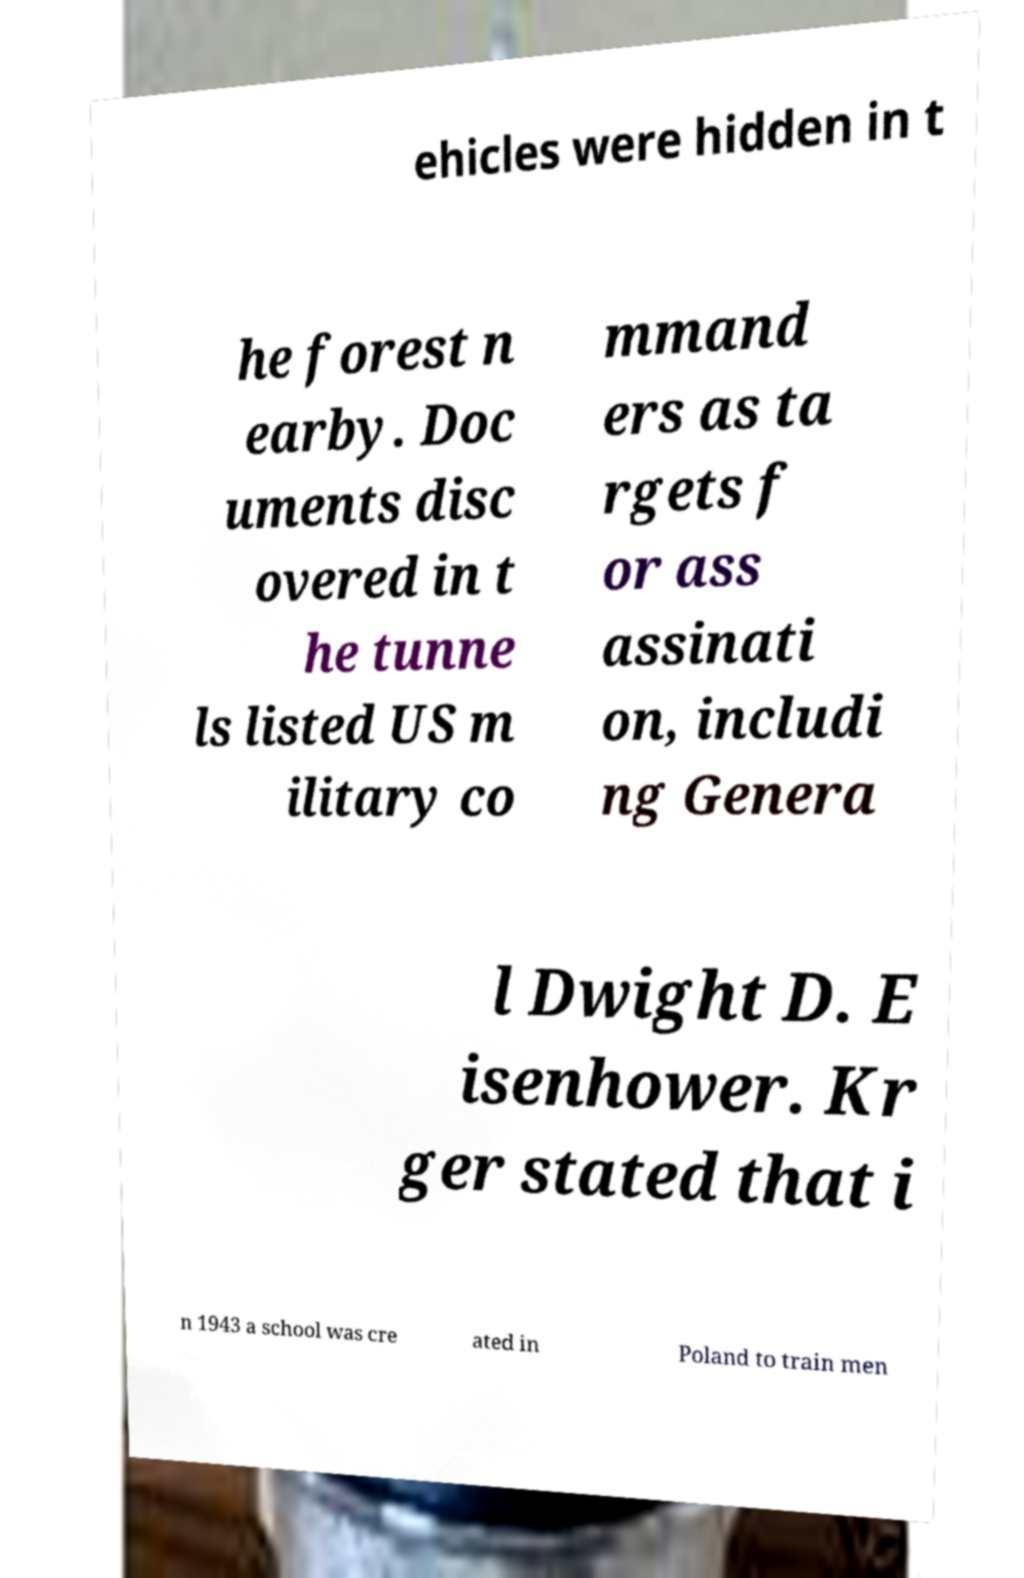Could you extract and type out the text from this image? ehicles were hidden in t he forest n earby. Doc uments disc overed in t he tunne ls listed US m ilitary co mmand ers as ta rgets f or ass assinati on, includi ng Genera l Dwight D. E isenhower. Kr ger stated that i n 1943 a school was cre ated in Poland to train men 